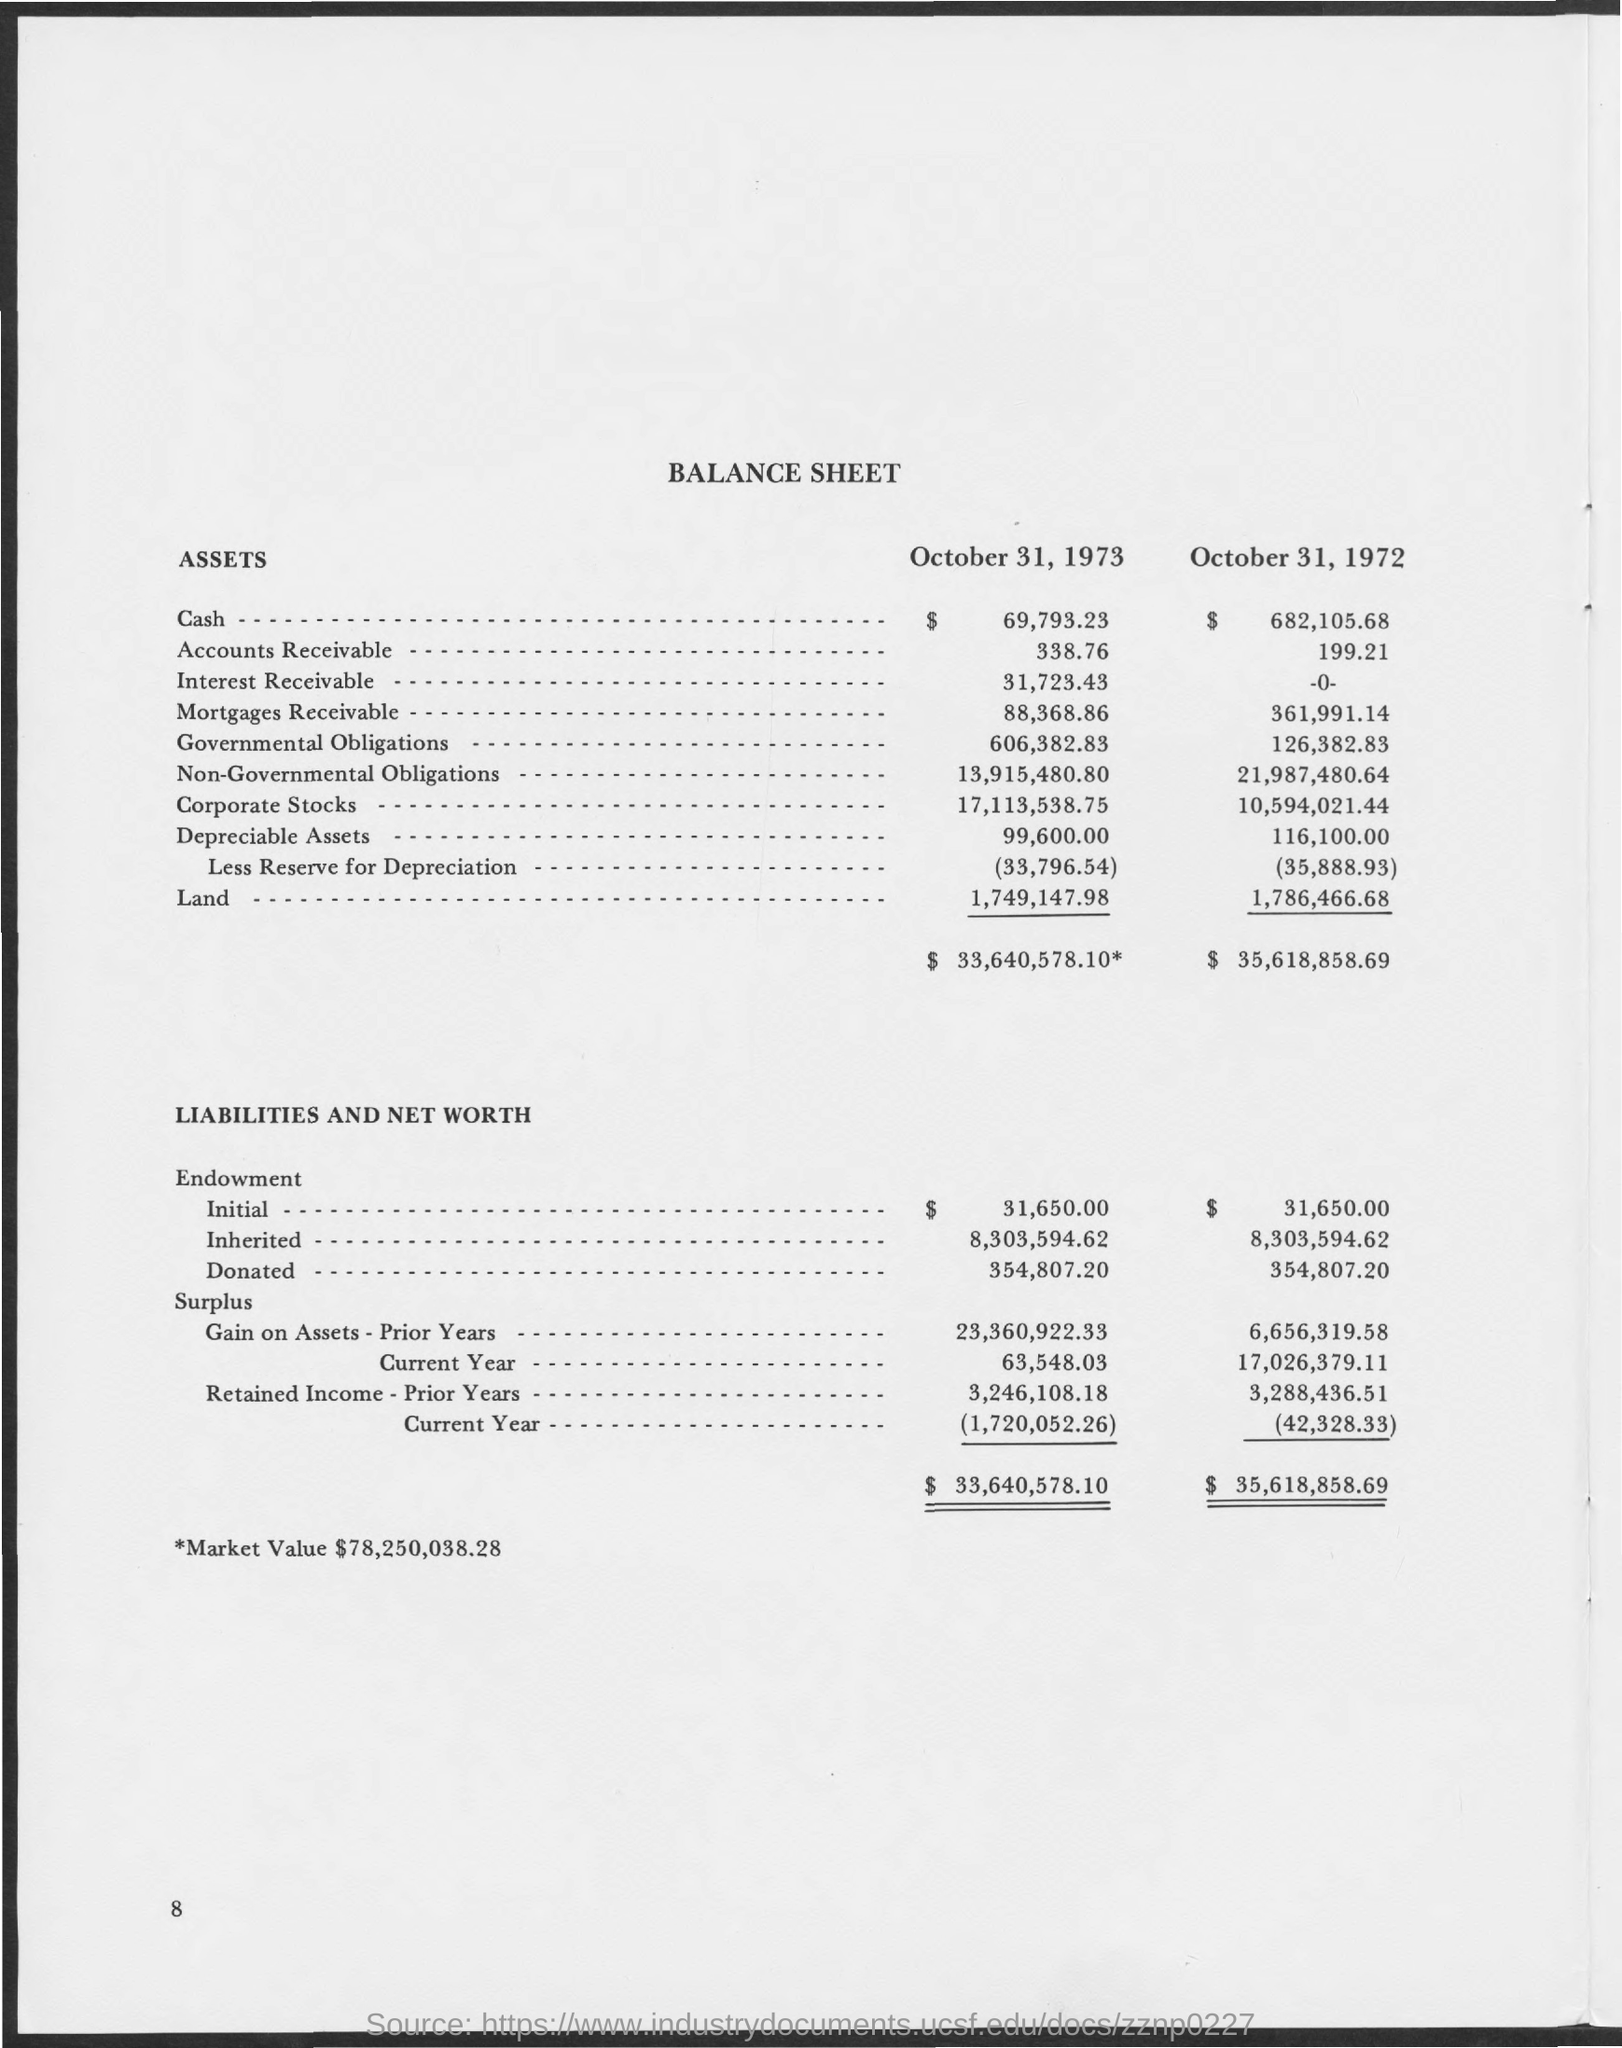How much Market Value mentioned in the Balance Sheet?
Offer a terse response. $ 78,250,038,28. 